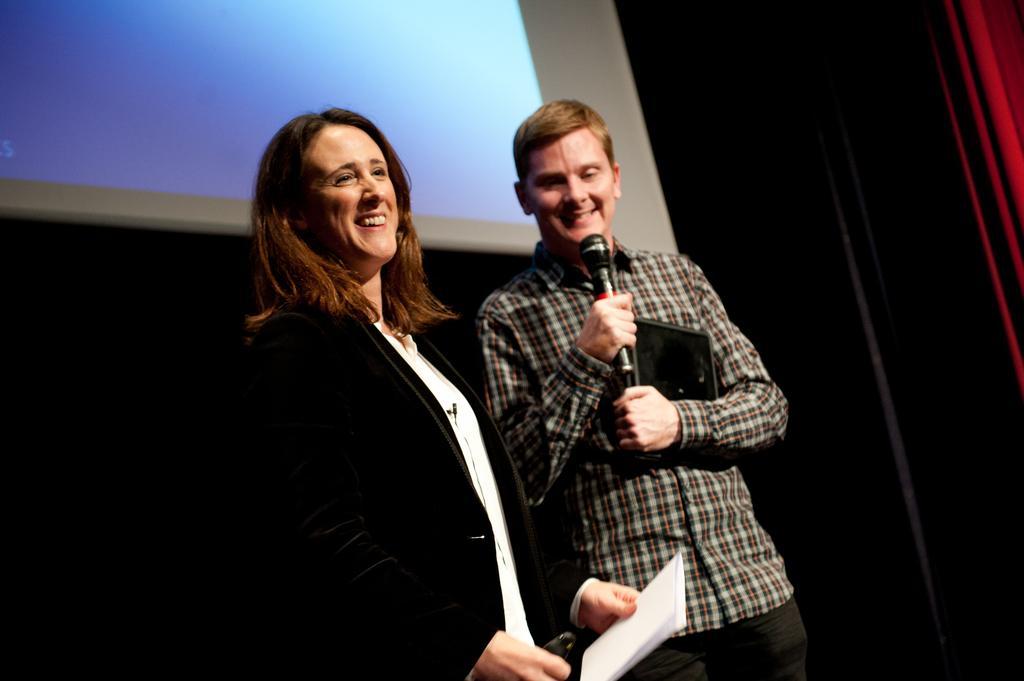In one or two sentences, can you explain what this image depicts? In this image I can see two people are standing and smiling. One is man and one is woman. The man is holding a mike and some other object in hand. The woman is holding a paper in her left hand. On the top of the image there is a red color curtain. 